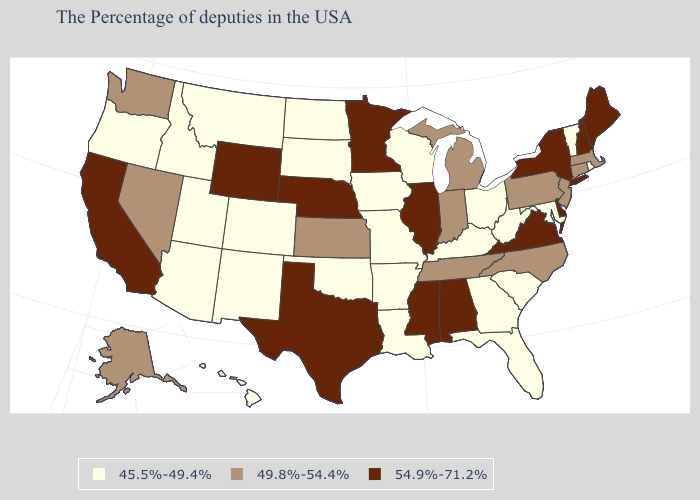Does Nebraska have the highest value in the USA?
Quick response, please. Yes. Does the first symbol in the legend represent the smallest category?
Give a very brief answer. Yes. Name the states that have a value in the range 54.9%-71.2%?
Be succinct. Maine, New Hampshire, New York, Delaware, Virginia, Alabama, Illinois, Mississippi, Minnesota, Nebraska, Texas, Wyoming, California. What is the value of Wisconsin?
Write a very short answer. 45.5%-49.4%. Name the states that have a value in the range 49.8%-54.4%?
Be succinct. Massachusetts, Connecticut, New Jersey, Pennsylvania, North Carolina, Michigan, Indiana, Tennessee, Kansas, Nevada, Washington, Alaska. Name the states that have a value in the range 49.8%-54.4%?
Short answer required. Massachusetts, Connecticut, New Jersey, Pennsylvania, North Carolina, Michigan, Indiana, Tennessee, Kansas, Nevada, Washington, Alaska. What is the value of Hawaii?
Answer briefly. 45.5%-49.4%. Does the map have missing data?
Concise answer only. No. What is the value of Arizona?
Keep it brief. 45.5%-49.4%. What is the value of Oregon?
Keep it brief. 45.5%-49.4%. Name the states that have a value in the range 45.5%-49.4%?
Be succinct. Rhode Island, Vermont, Maryland, South Carolina, West Virginia, Ohio, Florida, Georgia, Kentucky, Wisconsin, Louisiana, Missouri, Arkansas, Iowa, Oklahoma, South Dakota, North Dakota, Colorado, New Mexico, Utah, Montana, Arizona, Idaho, Oregon, Hawaii. Does the map have missing data?
Concise answer only. No. How many symbols are there in the legend?
Write a very short answer. 3. Name the states that have a value in the range 45.5%-49.4%?
Write a very short answer. Rhode Island, Vermont, Maryland, South Carolina, West Virginia, Ohio, Florida, Georgia, Kentucky, Wisconsin, Louisiana, Missouri, Arkansas, Iowa, Oklahoma, South Dakota, North Dakota, Colorado, New Mexico, Utah, Montana, Arizona, Idaho, Oregon, Hawaii. What is the value of Minnesota?
Concise answer only. 54.9%-71.2%. 